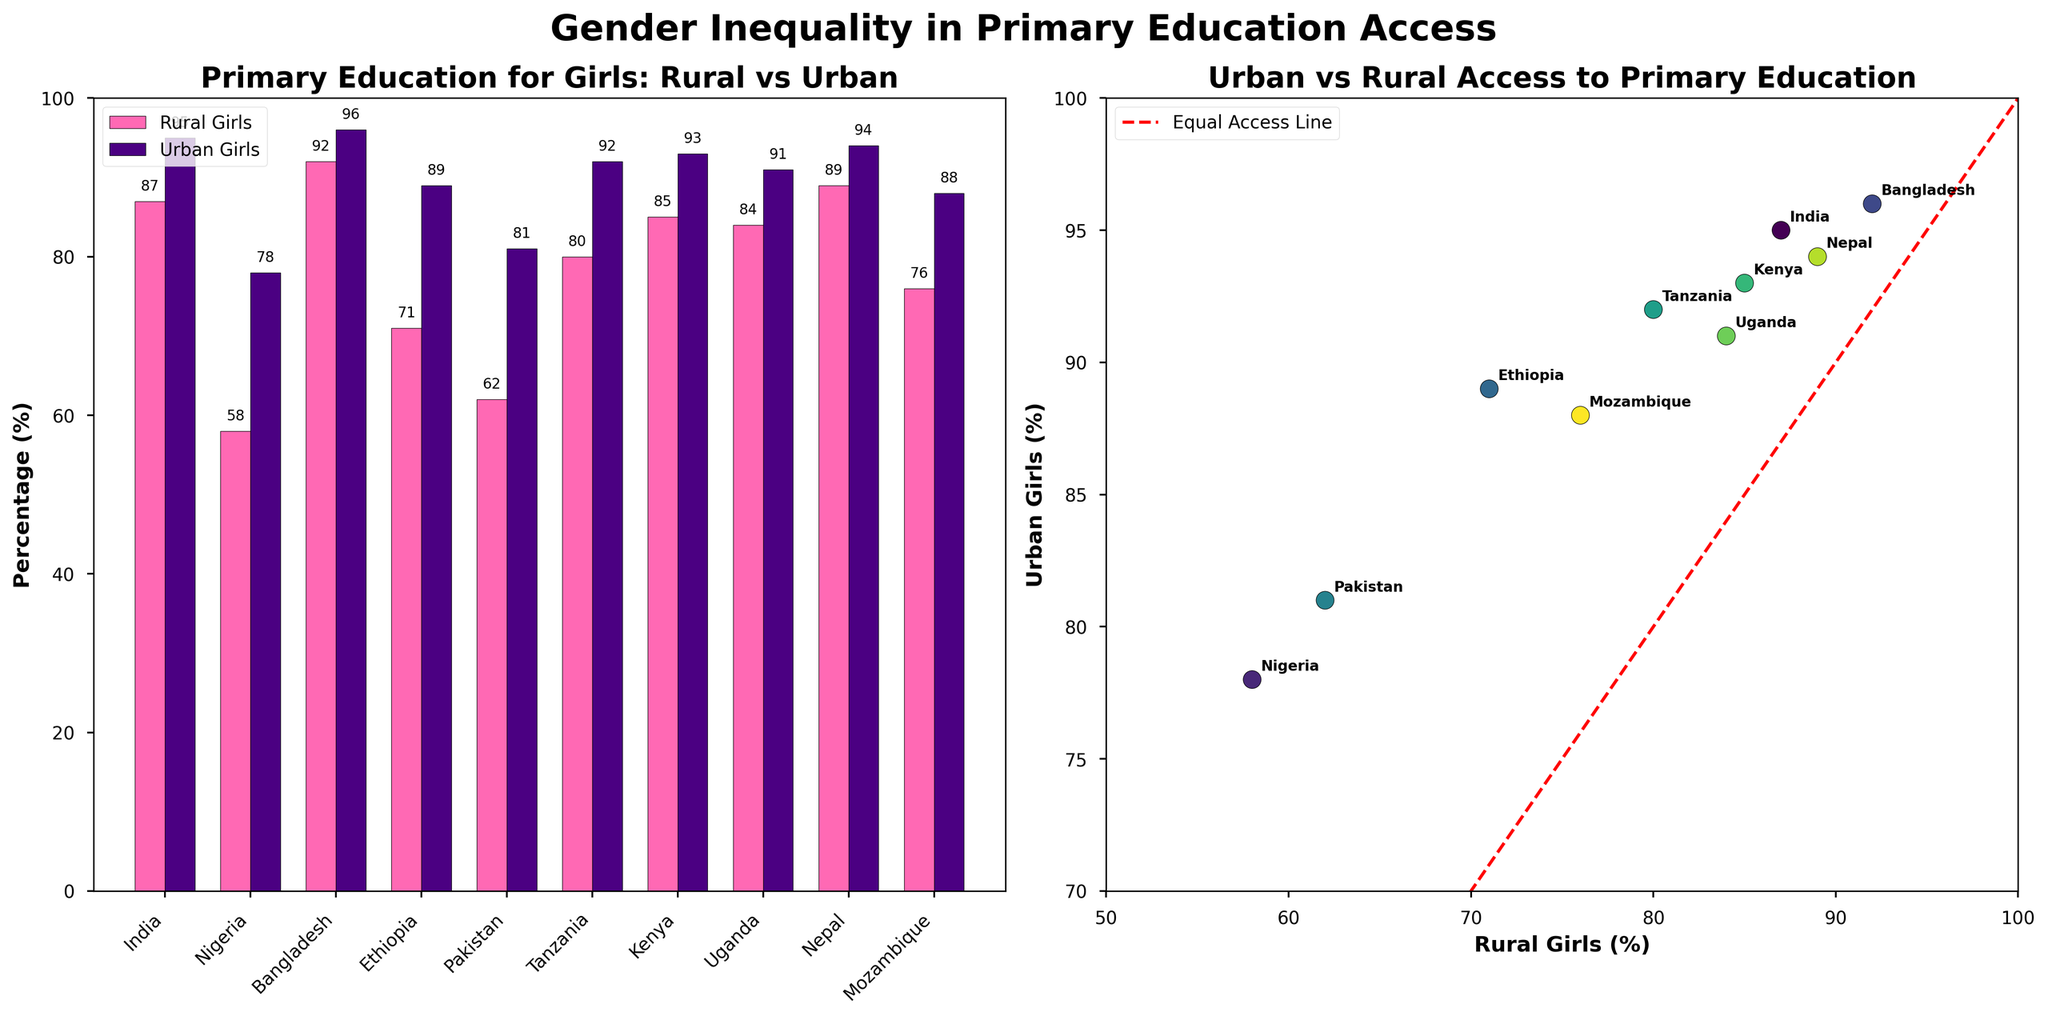What is the title of the bar chart on the left side? The title of the bar chart is displayed at the top of the left subplot. It reads "Primary Education for Girls: Rural vs Urban".
Answer: Primary Education for Girls: Rural vs Urban How many countries are represented in the data? The number of countries can be determined by counting the bars in the bar chart or the scatter points in the scatter plot. There are 10 countries listed.
Answer: 10 Which country has the highest percentage of rural girls receiving primary education? To find this, look at the tallest bar in the rural girls' section of the bar chart, or the highest x-value in the scatter plot. Bangladesh has the highest percentage with 92%.
Answer: Bangladesh How does the percentage of rural girls receiving primary education in Nigeria compare to urban girls in Nigeria? Find Nigeria on the bar chart and compare the length of the two bars. In Nigeria, 58% of rural girls and 78% of urban girls receive primary education. Urban girls have a higher percentage by 20%.
Answer: Urban girls have 20% higher What is the average percentage of primary education access for rural girls across all countries? Add the percentages of rural girls for all countries and divide by the number of countries (10): (87 + 58 + 92 + 71 + 62 + 80 + 85 + 84 + 89 + 76) / 10 = 78.4%.
Answer: 78.4% Which country shows the smallest difference between rural and urban girls receiving primary education? Calculate the difference for each country by subtracting the rural percentage from the urban percentage and finding the smallest result. Bangladesh shows the smallest difference with (96 - 92) = 4%.
Answer: Bangladesh Which country has the lowest percentage of urban girls receiving primary education? Identify the shortest bar in the urban girls' section of the bar chart or lowest y-value in the scatter plot. Nigeria has the lowest percentage with 78%.
Answer: Nigeria What does the red dashed line in the scatter plot represent? The red dashed line is labeled "Equal Access Line" and represents a scenario where rural and urban girls have equal access to primary education.
Answer: Equal Access Line Which countries have a percentage of rural girls receiving primary education higher than 80%? Check the bar lengths in the rural section or the x-axis values in the scatter plot. The countries are India, Bangladesh, Tanzania, Kenya, Uganda, and Nepal.
Answer: India, Bangladesh, Tanzania, Kenya, Uganda, Nepal What is the range of percentages for urban girls receiving primary education in all countries? Identify the highest and lowest percentages from the urban girls' section. The range is from Nigeria (78%) to Bangladesh (96%). The difference is 96 - 78 = 18%.
Answer: 18% 